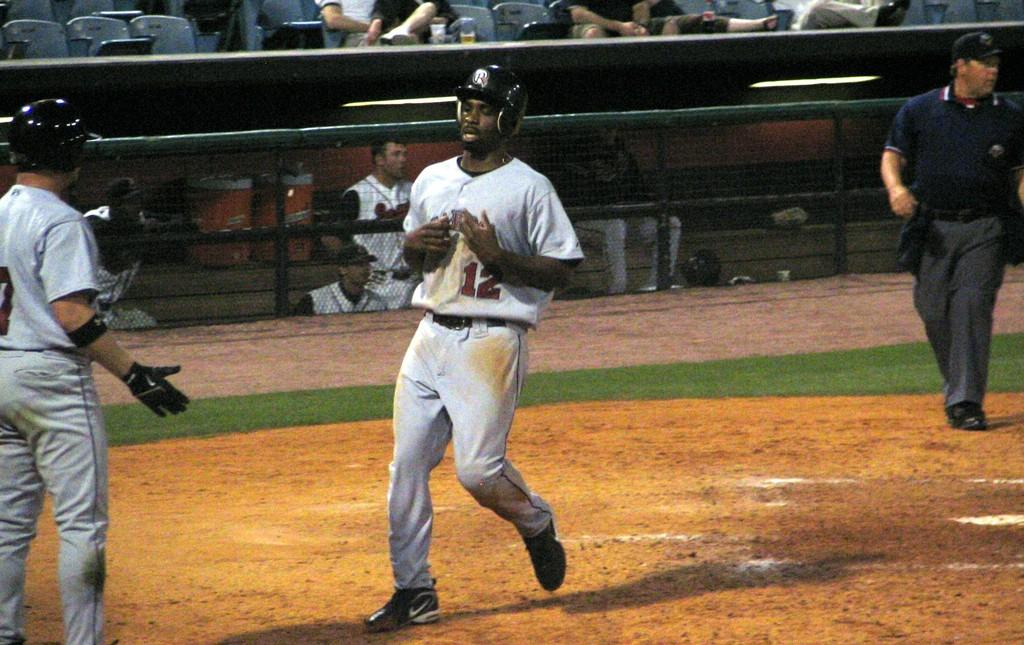How many people are on the ground in the image? There are three people on the ground in the image. What type of protective gear is visible in the image? Helmets are visible in the image. What type of headwear is present in the image? A cap is present in the image. What type of barrier is in the image? There is a fence in the image. What can be seen in the background of the image? In the background, there are people sitting on chairs, and there are other objects visible. What type of bed is visible in the image? There is no bed present in the image. What type of battle is taking place in the image? There is no battle present in the image. 